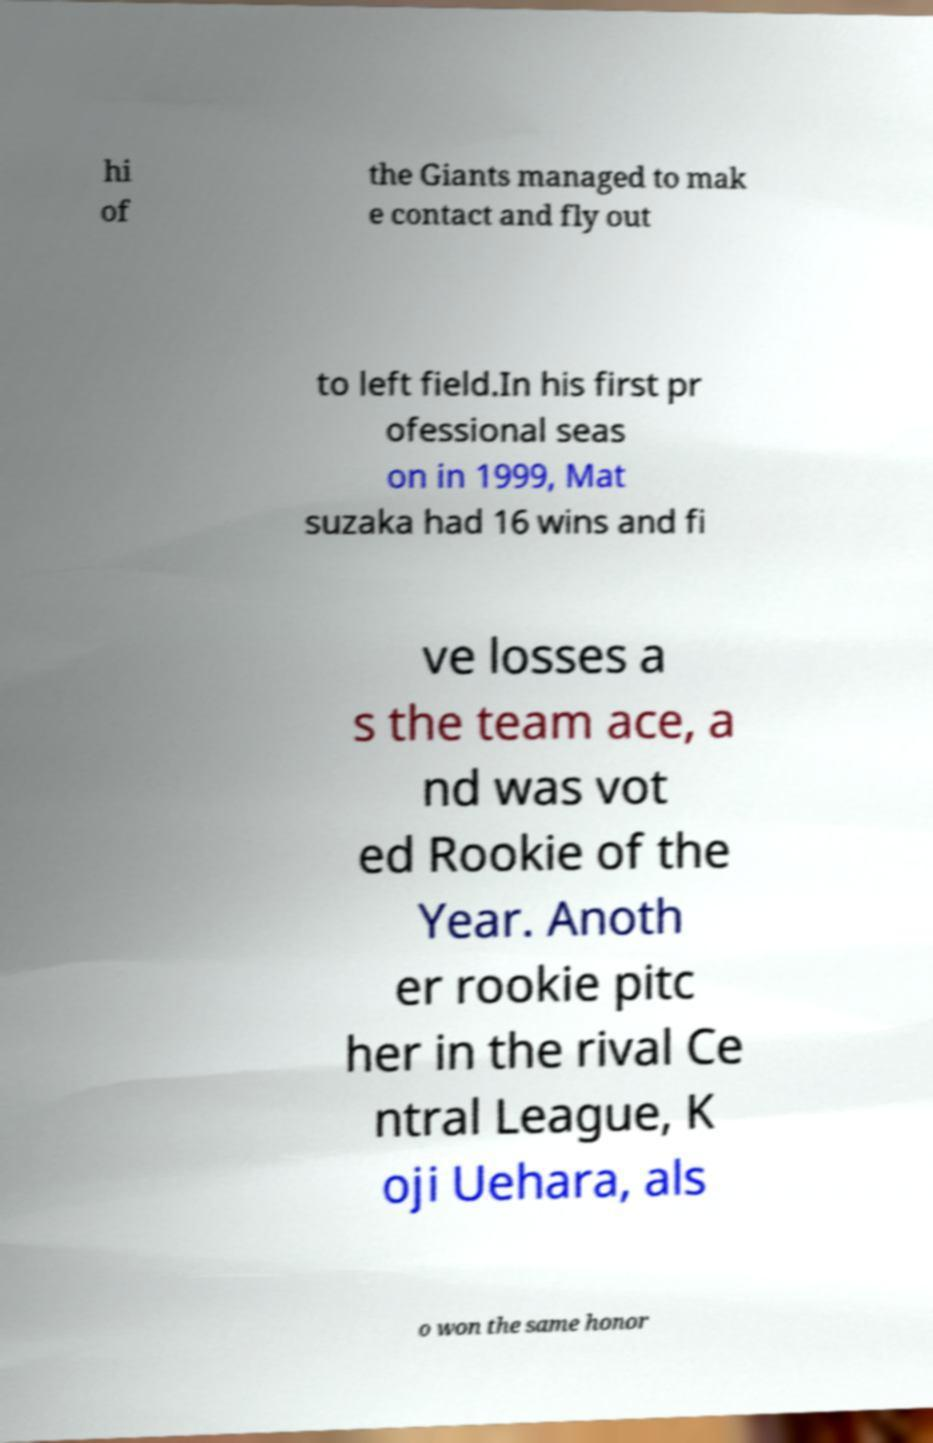I need the written content from this picture converted into text. Can you do that? hi of the Giants managed to mak e contact and fly out to left field.In his first pr ofessional seas on in 1999, Mat suzaka had 16 wins and fi ve losses a s the team ace, a nd was vot ed Rookie of the Year. Anoth er rookie pitc her in the rival Ce ntral League, K oji Uehara, als o won the same honor 